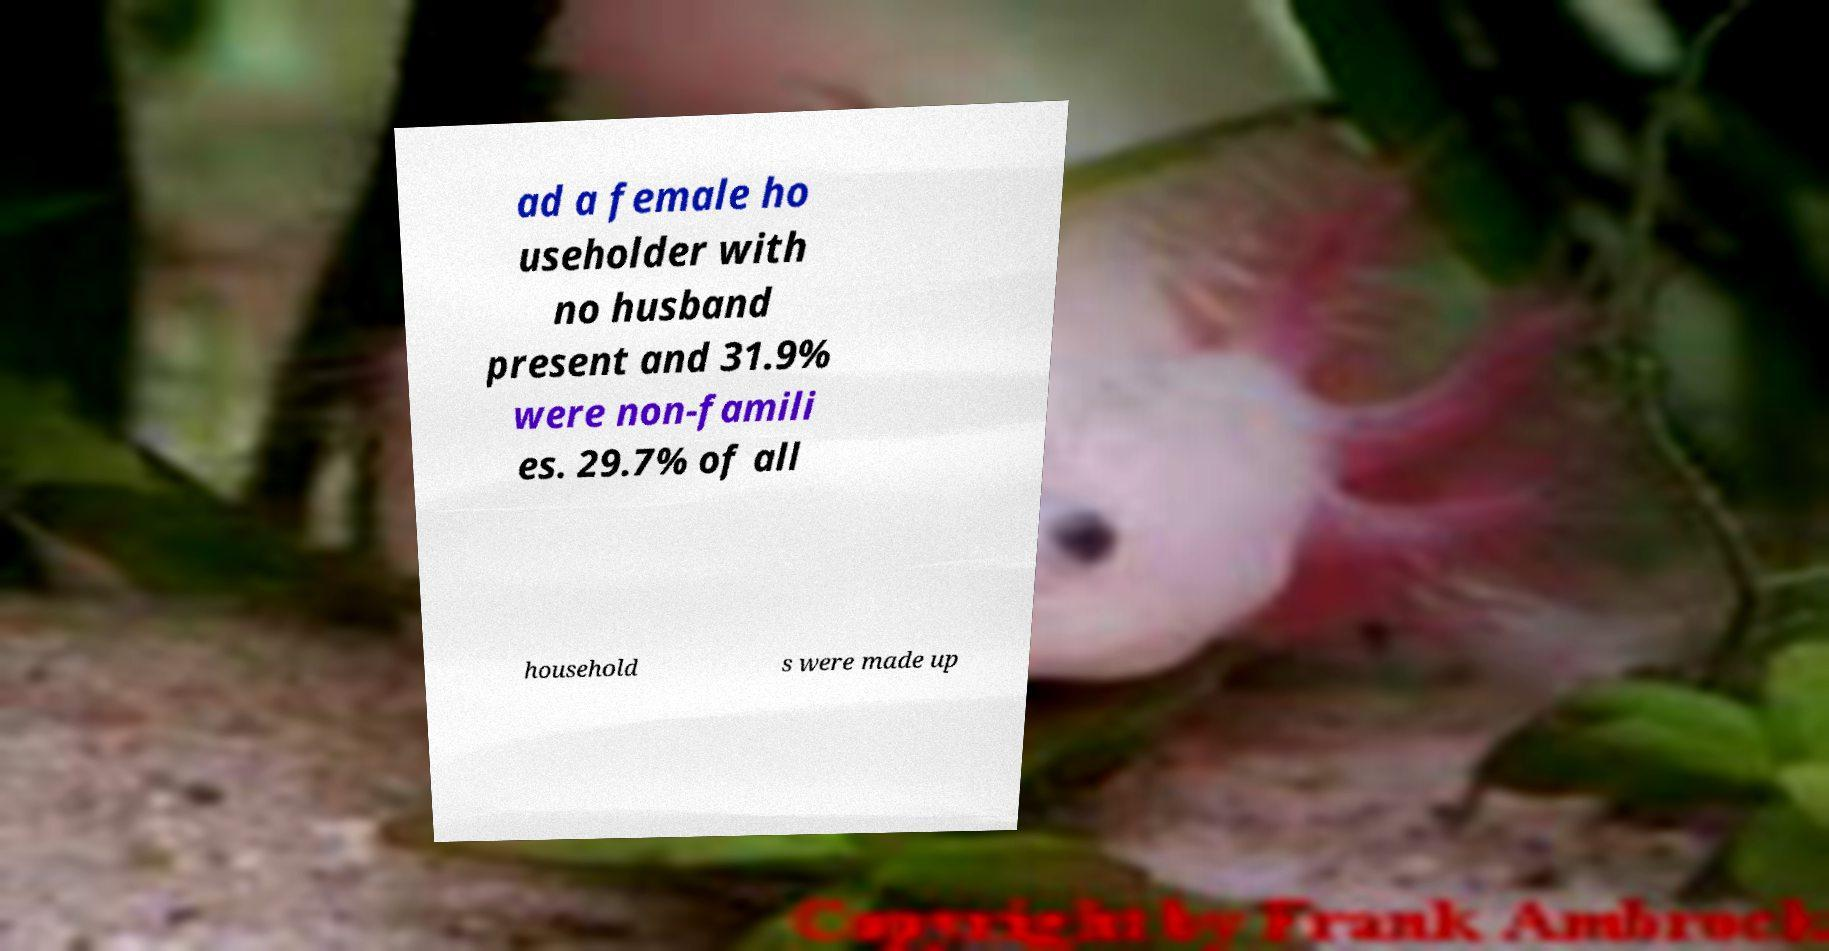Could you extract and type out the text from this image? ad a female ho useholder with no husband present and 31.9% were non-famili es. 29.7% of all household s were made up 